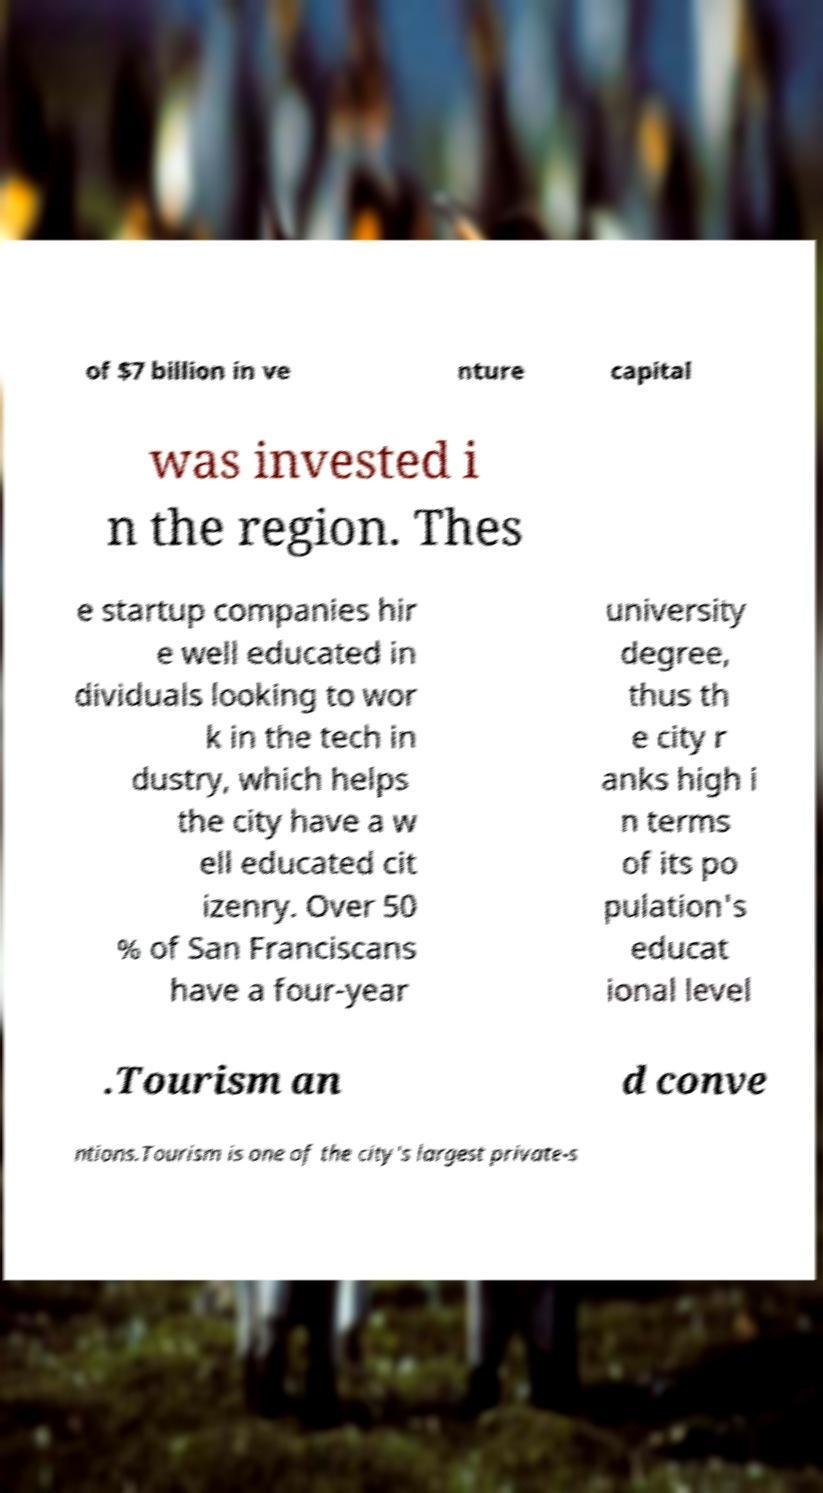Could you extract and type out the text from this image? of $7 billion in ve nture capital was invested i n the region. Thes e startup companies hir e well educated in dividuals looking to wor k in the tech in dustry, which helps the city have a w ell educated cit izenry. Over 50 % of San Franciscans have a four-year university degree, thus th e city r anks high i n terms of its po pulation's educat ional level .Tourism an d conve ntions.Tourism is one of the city's largest private-s 